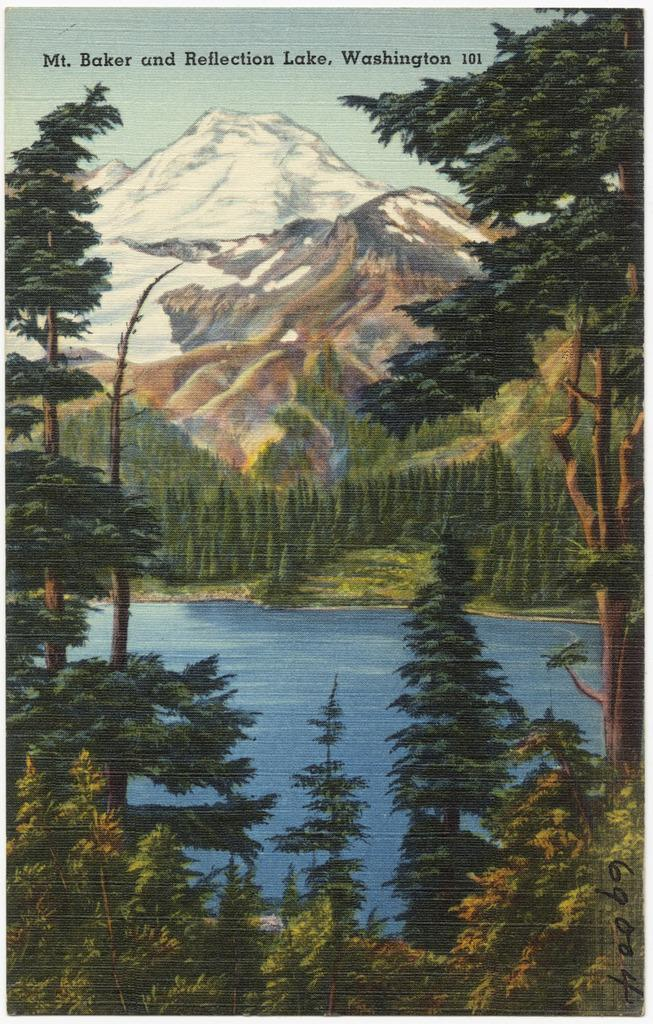What type of artwork is depicted in the image? The image is a painting. What natural features can be seen in the painting? There are mountains and trees in the painting. What body of water is present in the painting? There is water at the bottom of the painting. Where is the hose located in the painting? There is no hose present in the painting. Can you see any people walking in the painting? The painting does not depict any people walking. 